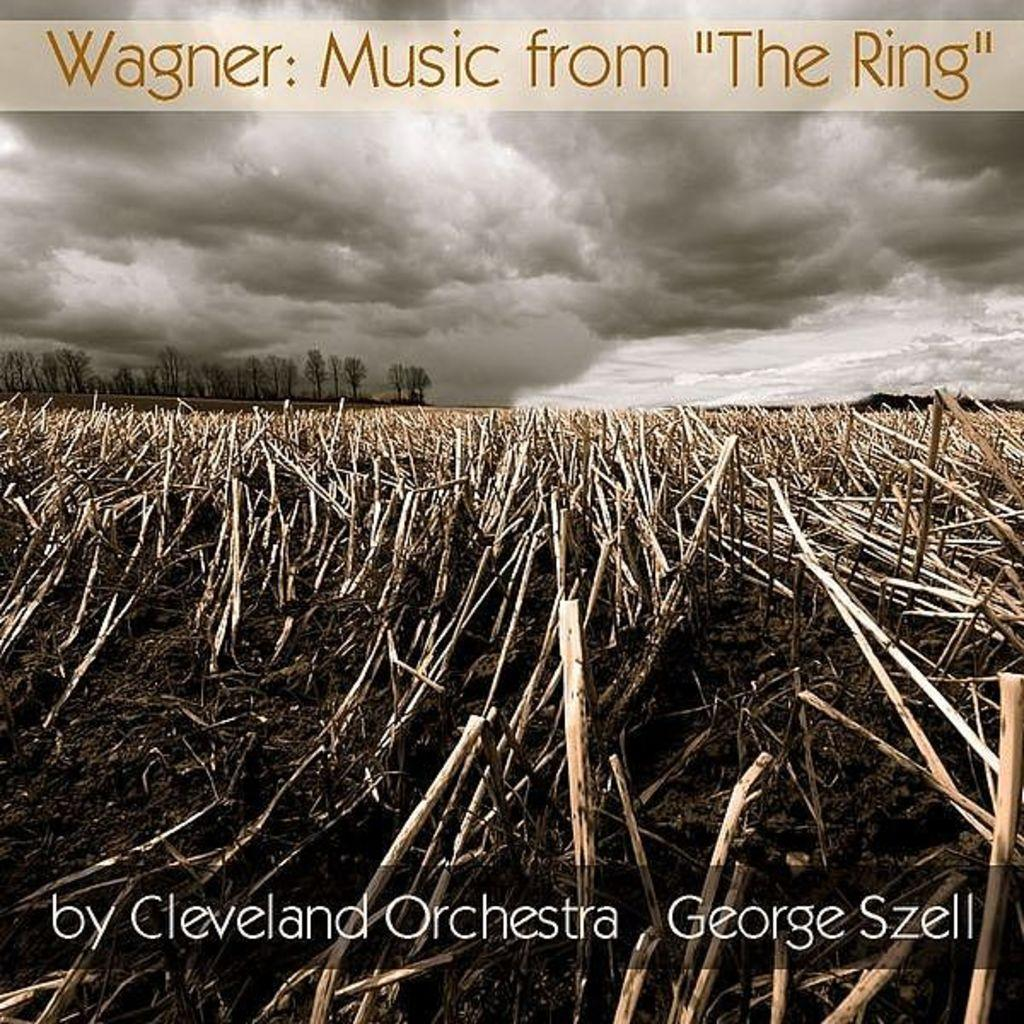What is featured on the poster in the image? The poster contains sticks, trees, and a cloudy sky. What type of weather is depicted in the poster? The poster contains a cloudy sky, which suggests a potentially overcast or rainy day. Are there any visible imperfections on the poster? A: Yes, there are watermarks visible in the image. What type of table is depicted in the image? There is no table present in the image; it features a poster with sticks, trees, and a cloudy sky. How does the poster make you feel when you look at it? The question of how the poster makes someone feel is subjective and cannot be definitively answered based on the provided facts. 